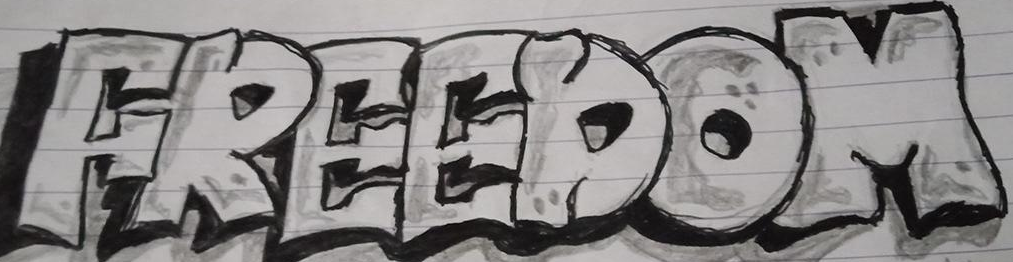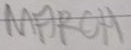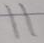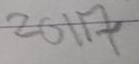What text is displayed in these images sequentially, separated by a semicolon? FREEDOM; MARCH; 11; 2017 